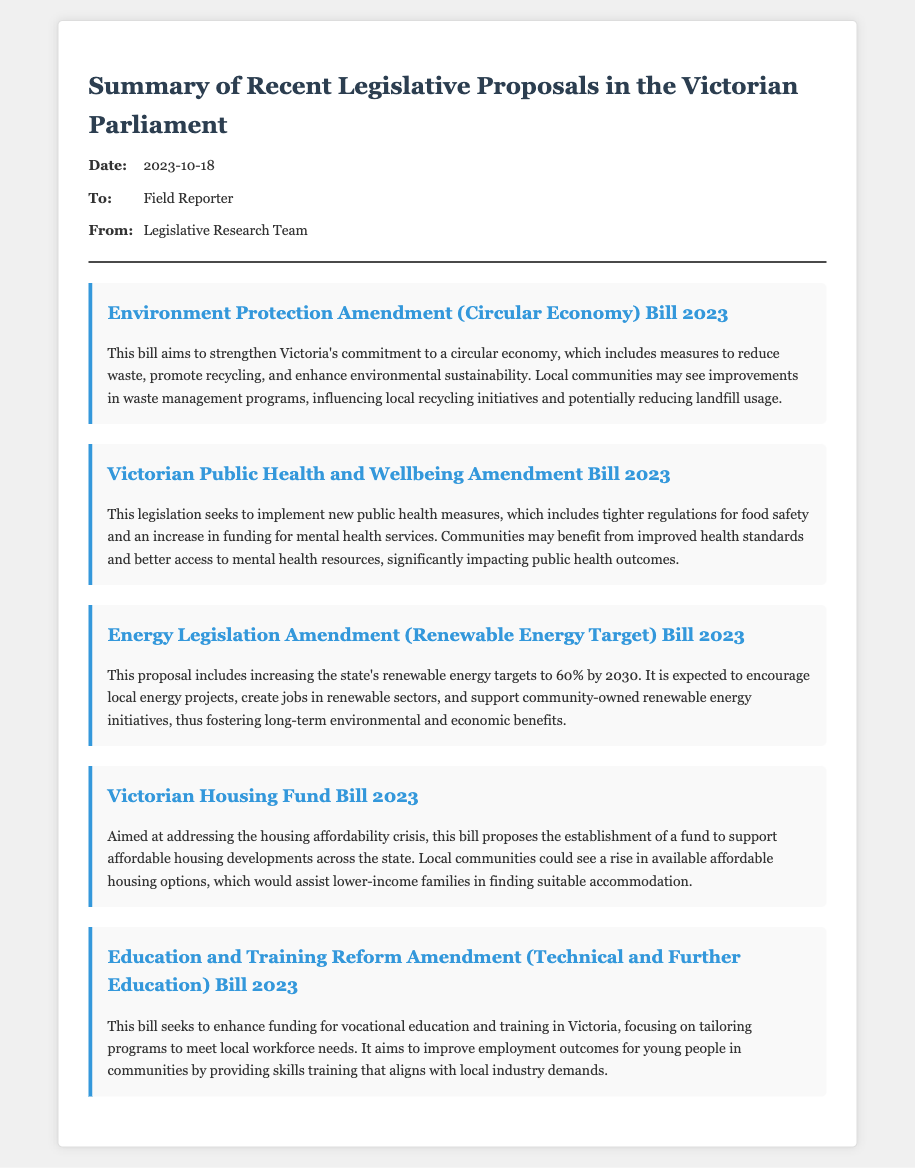What is the date of the memo? The date of the memo is stated in the header section of the document.
Answer: 2023-10-18 Who is the sender of the memo? The sender is specified in the "From" section of the meta information in the document.
Answer: Legislative Research Team What is the title of the proposal regarding housing affordability? The title can be found in the proposal section related to housing.
Answer: Victorian Housing Fund Bill 2023 What is the renewable energy target mentioned in the Energy Legislation Amendment Bill? The specific target is indicated in the description of the energy proposal in the document.
Answer: 60% Which legislative proposal focuses on public health? This is detailed in one of the proposals discussing health measures.
Answer: Victorian Public Health and Wellbeing Amendment Bill 2023 What community benefit is expected from the Environment Protection Amendment Bill? The expected benefit is summarized in the description of the bill.
Answer: Improvements in waste management programs How does the Education and Training Reform Amendment Bill aim to assist young people? This information can be derived from the explanation of the bill's objectives in the document.
Answer: Improve employment outcomes What is the primary focus of the Energy Legislation Amendment Bill? The main focus of the bill is described in the opening statement of the proposal.
Answer: Increasing the state's renewable energy targets What type of economy does the Environment Protection Amendment Bill aim to promote? This is a key point in the description of the proposal regarding environment and sustainability.
Answer: Circular economy 